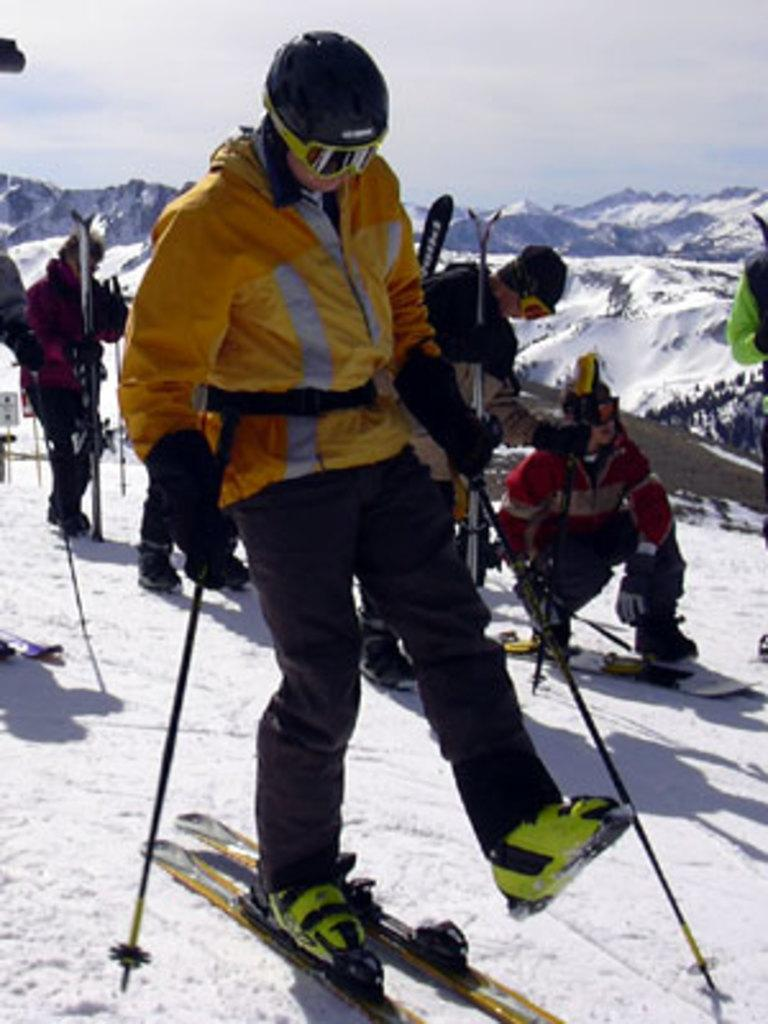What is the person in the image doing? There is a person on a skateboard in the image. What type of terrain is the person skating on? The person is skating on snow. Are there any other people in the image? Yes, there are people behind the skateboarder. What can be seen in the background of the image? Snow-covered mountains are visible in the background. What is visible above the skateboarder and the people in the image? The sky is visible in the image. What type of force is being applied to the ball by the skateboarder in the image? There is no ball present in the image, so no force is being applied to a ball by the skateboarder. What muscle is being used by the skateboarder to maintain balance in the image? The image does not show the skateboarder's muscles, so it is not possible to determine which muscle is being used to maintain balance. 